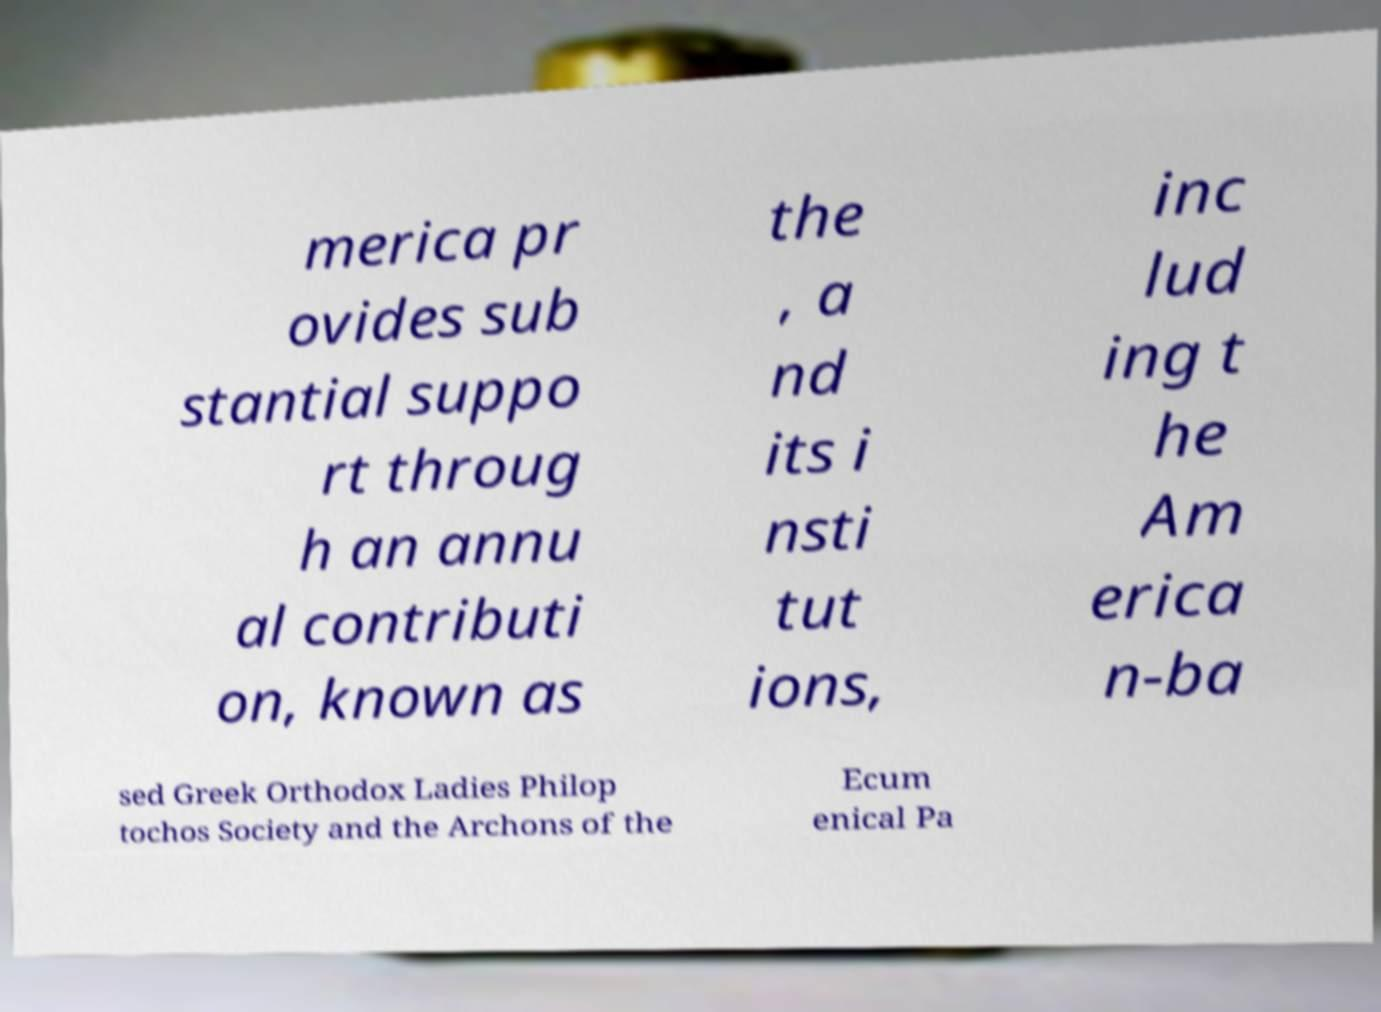Could you extract and type out the text from this image? merica pr ovides sub stantial suppo rt throug h an annu al contributi on, known as the , a nd its i nsti tut ions, inc lud ing t he Am erica n-ba sed Greek Orthodox Ladies Philop tochos Society and the Archons of the Ecum enical Pa 